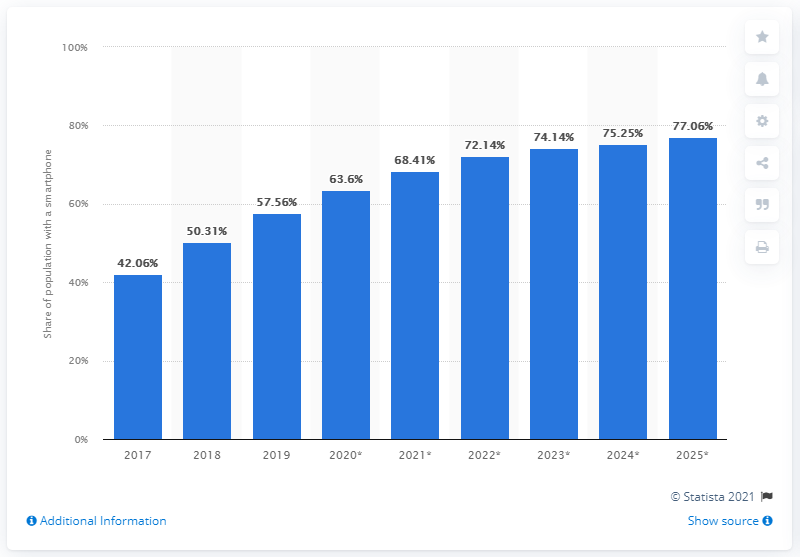Outline some significant characteristics in this image. In 2019, approximately 57.56% of the population in the Philippines used a smartphone. By 2025, it is projected that 77.06% of the population will be using smartphones. 